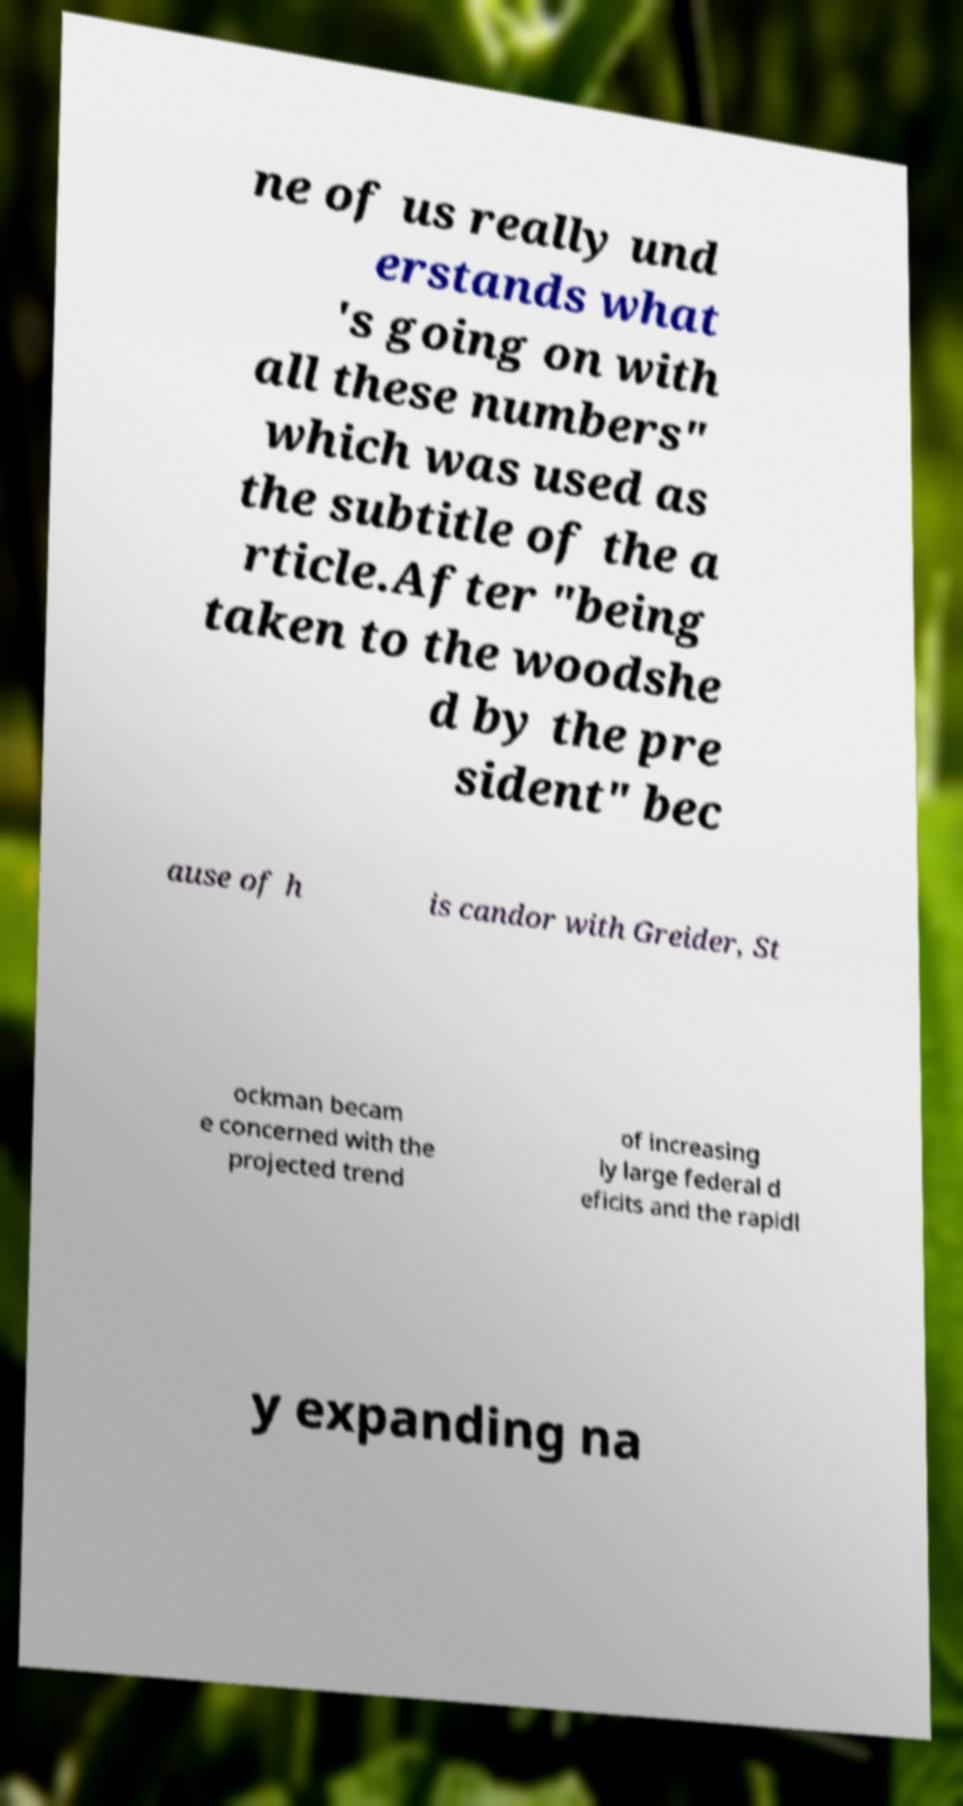I need the written content from this picture converted into text. Can you do that? ne of us really und erstands what 's going on with all these numbers" which was used as the subtitle of the a rticle.After "being taken to the woodshe d by the pre sident" bec ause of h is candor with Greider, St ockman becam e concerned with the projected trend of increasing ly large federal d eficits and the rapidl y expanding na 